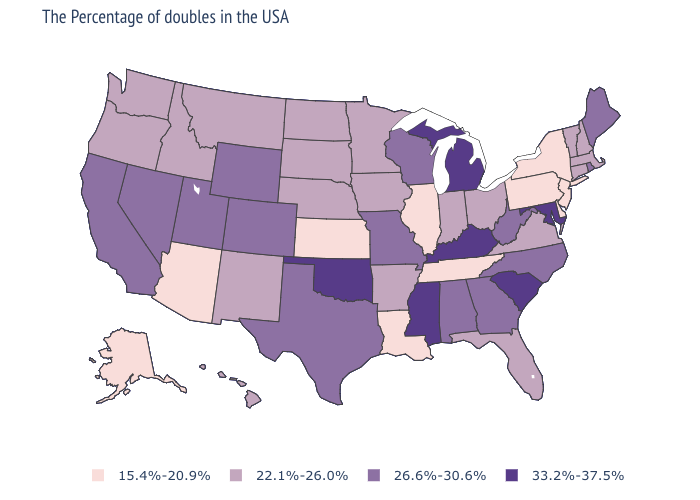Does Kentucky have the highest value in the USA?
Give a very brief answer. Yes. Name the states that have a value in the range 26.6%-30.6%?
Be succinct. Maine, Rhode Island, North Carolina, West Virginia, Georgia, Alabama, Wisconsin, Missouri, Texas, Wyoming, Colorado, Utah, Nevada, California. What is the value of Mississippi?
Write a very short answer. 33.2%-37.5%. Does Kentucky have the highest value in the USA?
Keep it brief. Yes. Does the first symbol in the legend represent the smallest category?
Concise answer only. Yes. What is the highest value in the MidWest ?
Write a very short answer. 33.2%-37.5%. What is the value of Georgia?
Give a very brief answer. 26.6%-30.6%. Does the map have missing data?
Short answer required. No. Does Missouri have the lowest value in the USA?
Concise answer only. No. Name the states that have a value in the range 33.2%-37.5%?
Give a very brief answer. Maryland, South Carolina, Michigan, Kentucky, Mississippi, Oklahoma. Which states hav the highest value in the Northeast?
Short answer required. Maine, Rhode Island. Does the map have missing data?
Give a very brief answer. No. Name the states that have a value in the range 15.4%-20.9%?
Short answer required. New York, New Jersey, Delaware, Pennsylvania, Tennessee, Illinois, Louisiana, Kansas, Arizona, Alaska. Which states have the lowest value in the South?
Be succinct. Delaware, Tennessee, Louisiana. How many symbols are there in the legend?
Concise answer only. 4. 